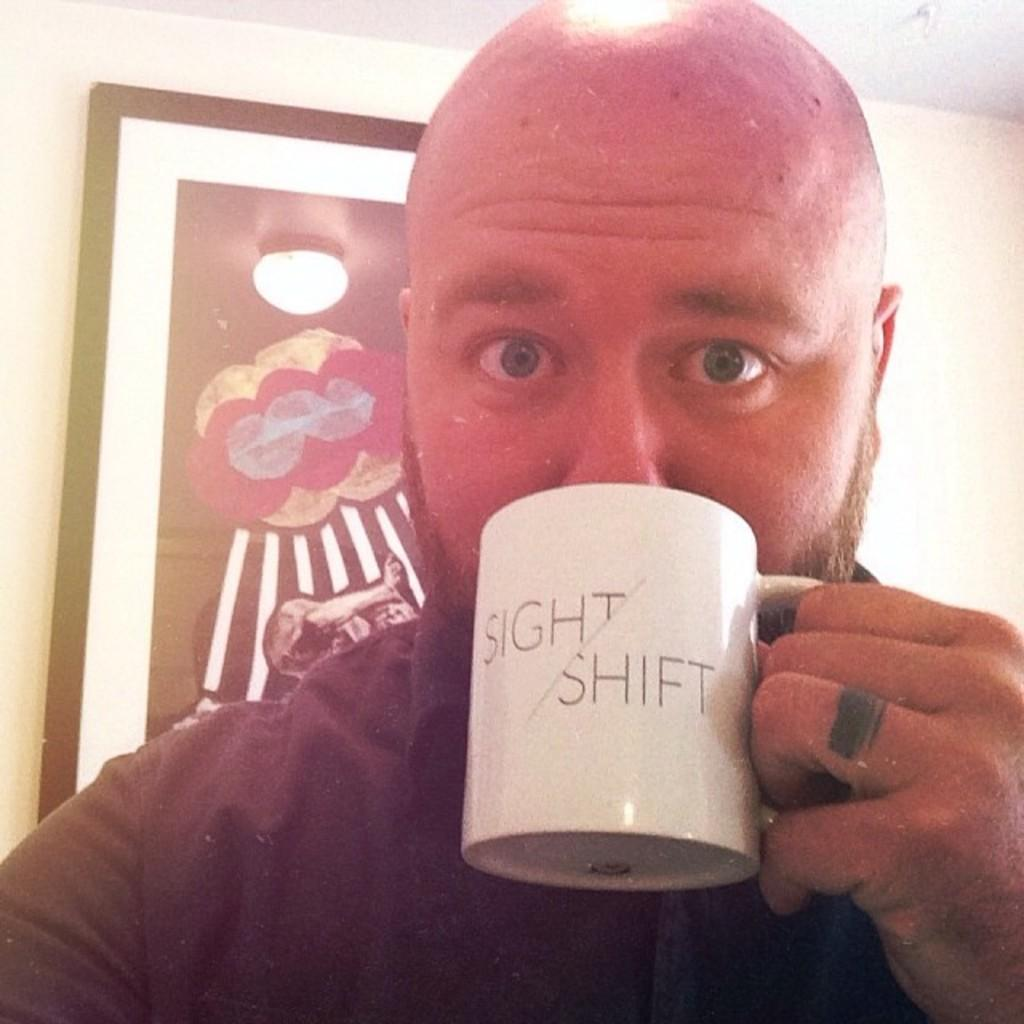<image>
Create a compact narrative representing the image presented. A bald man stares at the camera drinking from a cup saying sight shift. 